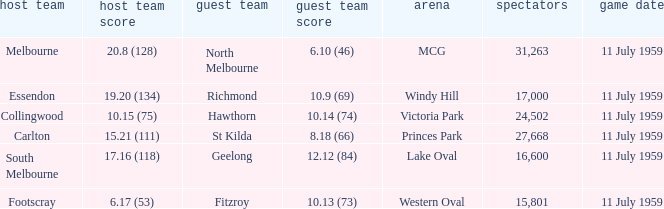How many points does footscray score as the home side? 6.17 (53). 